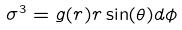<formula> <loc_0><loc_0><loc_500><loc_500>\sigma ^ { 3 } = g ( r ) r \sin ( \theta ) d \phi</formula> 